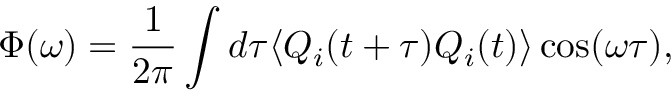Convert formula to latex. <formula><loc_0><loc_0><loc_500><loc_500>\Phi ( \omega ) = \frac { 1 } { 2 \pi } \int d \tau \langle Q _ { i } ( t + \tau ) Q _ { i } ( t ) \rangle \cos ( \omega \tau ) ,</formula> 